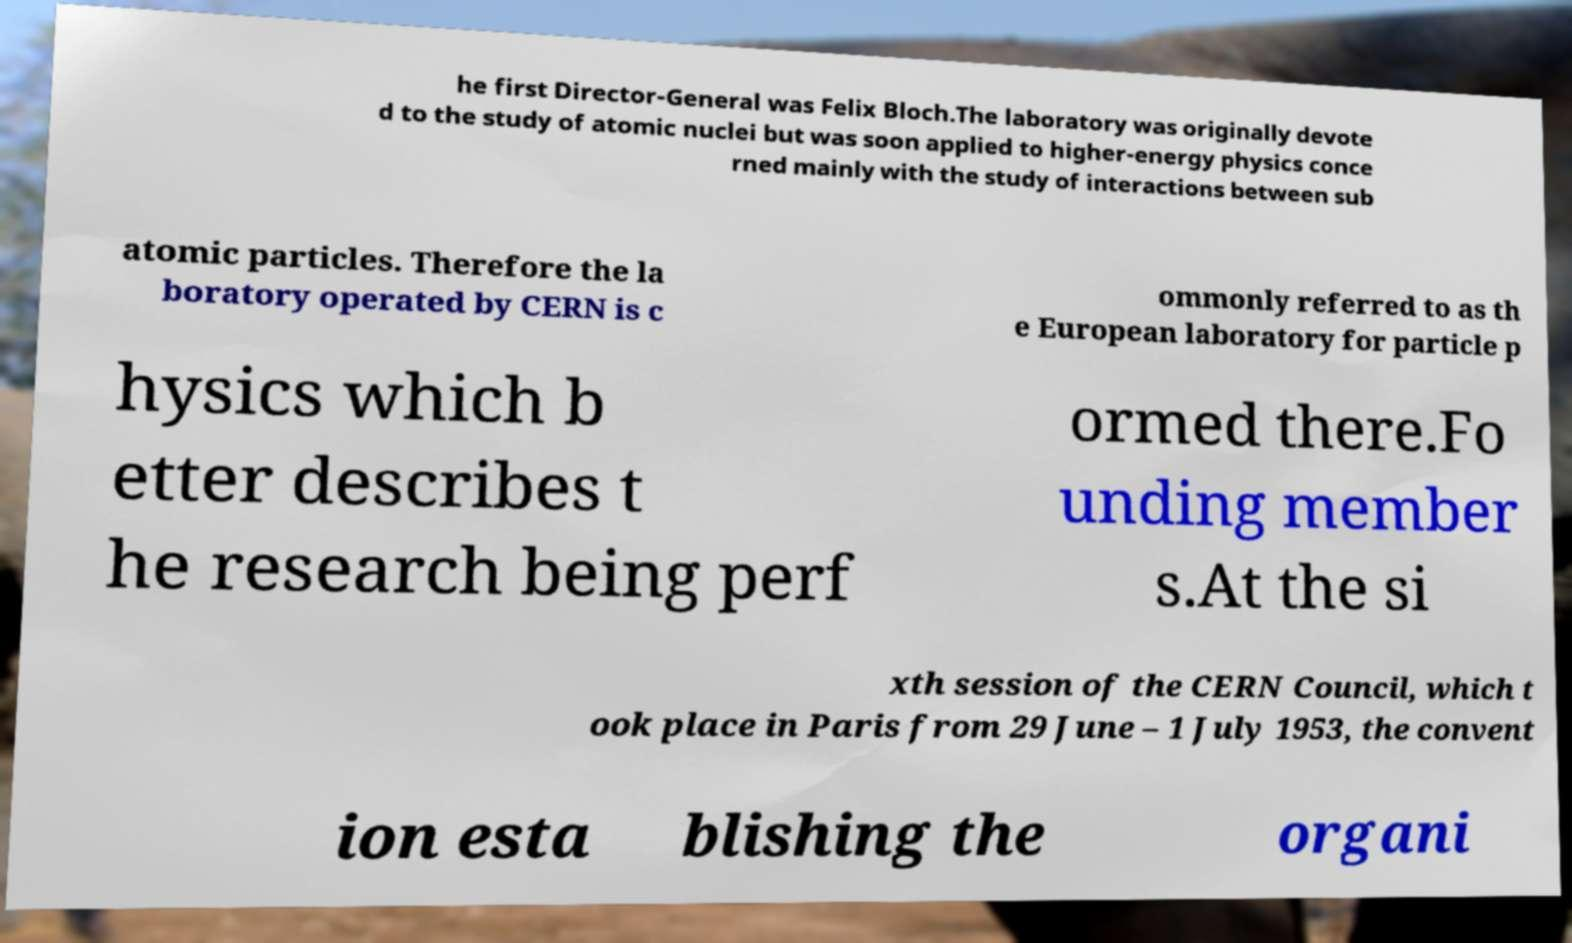Can you accurately transcribe the text from the provided image for me? he first Director-General was Felix Bloch.The laboratory was originally devote d to the study of atomic nuclei but was soon applied to higher-energy physics conce rned mainly with the study of interactions between sub atomic particles. Therefore the la boratory operated by CERN is c ommonly referred to as th e European laboratory for particle p hysics which b etter describes t he research being perf ormed there.Fo unding member s.At the si xth session of the CERN Council, which t ook place in Paris from 29 June – 1 July 1953, the convent ion esta blishing the organi 